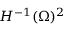Convert formula to latex. <formula><loc_0><loc_0><loc_500><loc_500>H ^ { - 1 } ( \Omega ) ^ { 2 }</formula> 